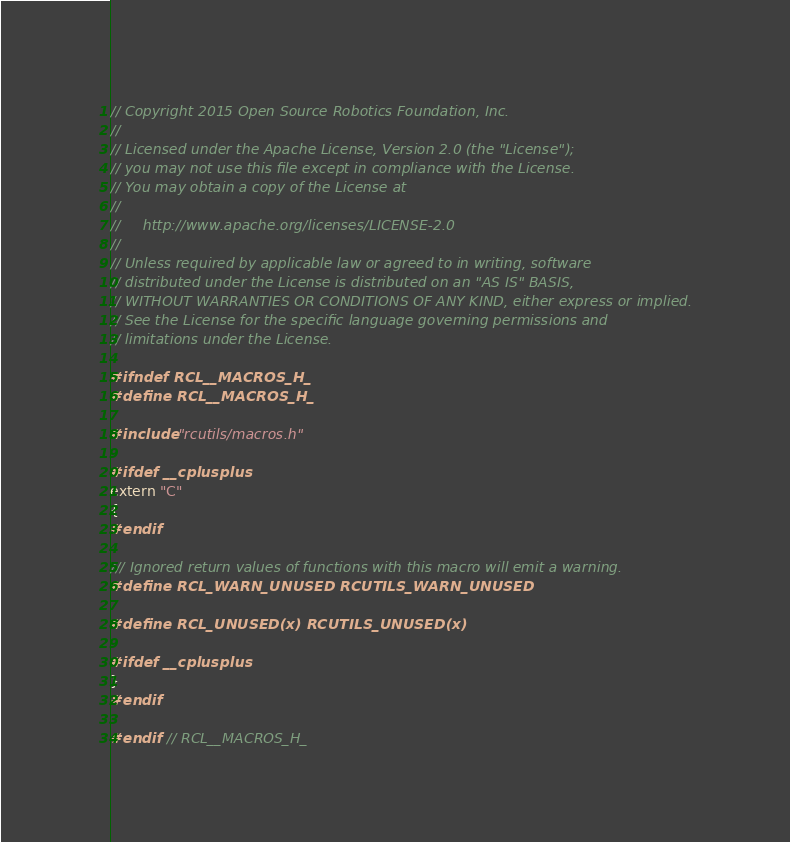Convert code to text. <code><loc_0><loc_0><loc_500><loc_500><_C_>// Copyright 2015 Open Source Robotics Foundation, Inc.
//
// Licensed under the Apache License, Version 2.0 (the "License");
// you may not use this file except in compliance with the License.
// You may obtain a copy of the License at
//
//     http://www.apache.org/licenses/LICENSE-2.0
//
// Unless required by applicable law or agreed to in writing, software
// distributed under the License is distributed on an "AS IS" BASIS,
// WITHOUT WARRANTIES OR CONDITIONS OF ANY KIND, either express or implied.
// See the License for the specific language governing permissions and
// limitations under the License.

#ifndef RCL__MACROS_H_
#define RCL__MACROS_H_

#include "rcutils/macros.h"

#ifdef __cplusplus
extern "C"
{
#endif

/// Ignored return values of functions with this macro will emit a warning.
#define RCL_WARN_UNUSED RCUTILS_WARN_UNUSED

#define RCL_UNUSED(x) RCUTILS_UNUSED(x)

#ifdef __cplusplus
}
#endif

#endif  // RCL__MACROS_H_
</code> 